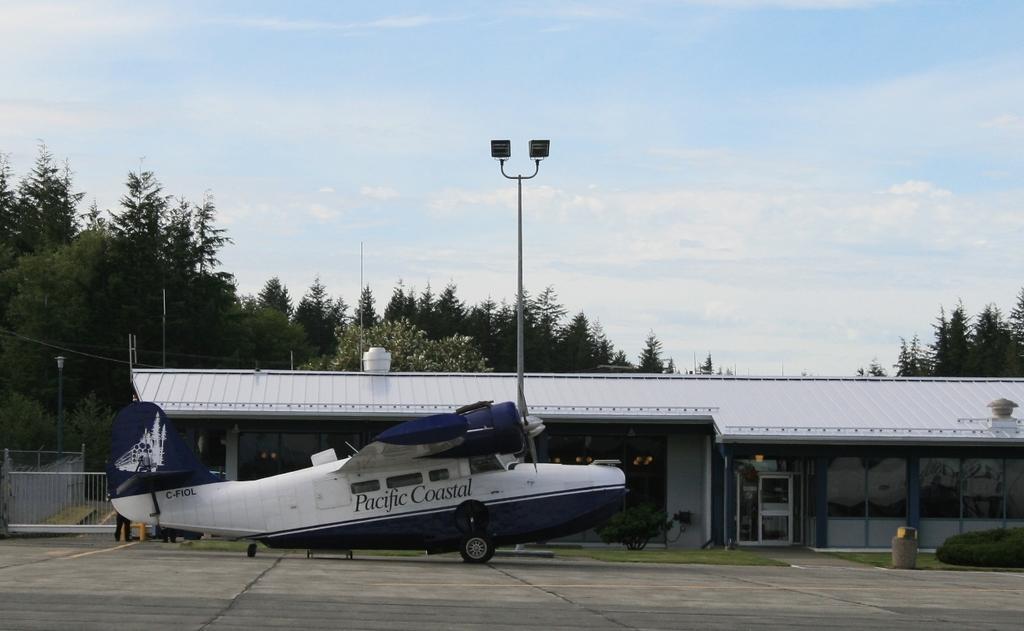In one or two sentences, can you explain what this image depicts? In the middle of the image there is a plane. Behind the plane there are some plants, grass and shed and poles. Behind the shed there are some trees. At the top of the image there are some clouds and sky. 